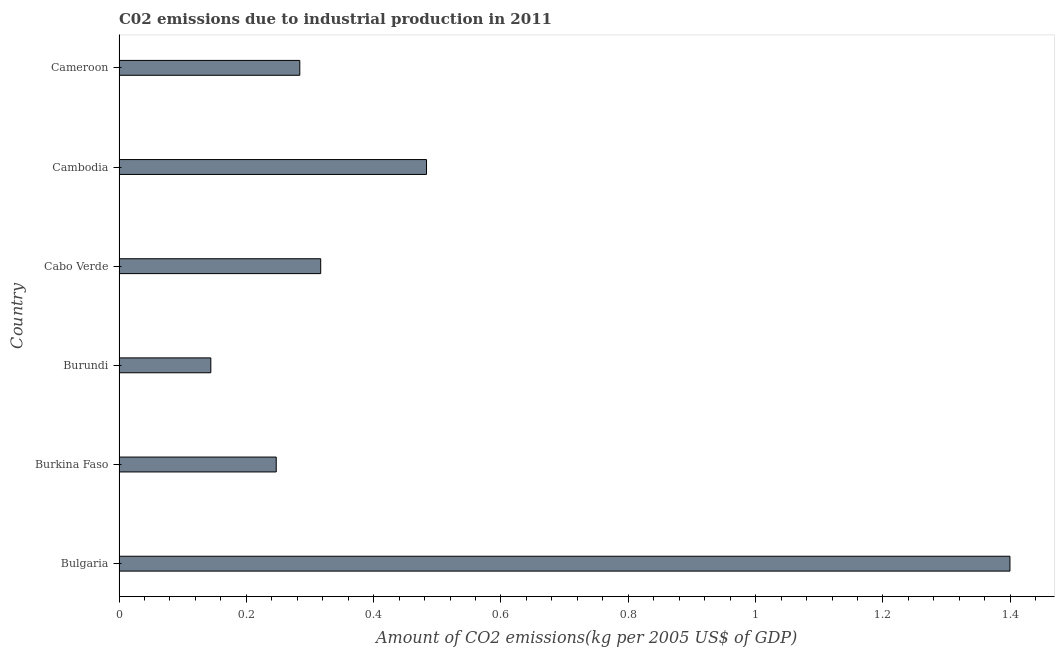Does the graph contain any zero values?
Your answer should be compact. No. What is the title of the graph?
Your answer should be compact. C02 emissions due to industrial production in 2011. What is the label or title of the X-axis?
Make the answer very short. Amount of CO2 emissions(kg per 2005 US$ of GDP). What is the amount of co2 emissions in Cabo Verde?
Your response must be concise. 0.32. Across all countries, what is the maximum amount of co2 emissions?
Provide a succinct answer. 1.4. Across all countries, what is the minimum amount of co2 emissions?
Offer a very short reply. 0.14. In which country was the amount of co2 emissions maximum?
Your answer should be very brief. Bulgaria. In which country was the amount of co2 emissions minimum?
Your response must be concise. Burundi. What is the sum of the amount of co2 emissions?
Your answer should be compact. 2.87. What is the difference between the amount of co2 emissions in Burkina Faso and Cabo Verde?
Offer a terse response. -0.07. What is the average amount of co2 emissions per country?
Offer a very short reply. 0.48. What is the median amount of co2 emissions?
Ensure brevity in your answer.  0.3. What is the ratio of the amount of co2 emissions in Cabo Verde to that in Cambodia?
Keep it short and to the point. 0.66. Is the amount of co2 emissions in Bulgaria less than that in Cameroon?
Give a very brief answer. No. Is the difference between the amount of co2 emissions in Bulgaria and Cabo Verde greater than the difference between any two countries?
Offer a terse response. No. What is the difference between the highest and the second highest amount of co2 emissions?
Make the answer very short. 0.92. What is the difference between the highest and the lowest amount of co2 emissions?
Ensure brevity in your answer.  1.26. Are all the bars in the graph horizontal?
Your answer should be compact. Yes. What is the difference between two consecutive major ticks on the X-axis?
Provide a succinct answer. 0.2. Are the values on the major ticks of X-axis written in scientific E-notation?
Provide a short and direct response. No. What is the Amount of CO2 emissions(kg per 2005 US$ of GDP) of Bulgaria?
Ensure brevity in your answer.  1.4. What is the Amount of CO2 emissions(kg per 2005 US$ of GDP) of Burkina Faso?
Provide a succinct answer. 0.25. What is the Amount of CO2 emissions(kg per 2005 US$ of GDP) of Burundi?
Ensure brevity in your answer.  0.14. What is the Amount of CO2 emissions(kg per 2005 US$ of GDP) in Cabo Verde?
Your answer should be very brief. 0.32. What is the Amount of CO2 emissions(kg per 2005 US$ of GDP) of Cambodia?
Offer a terse response. 0.48. What is the Amount of CO2 emissions(kg per 2005 US$ of GDP) of Cameroon?
Make the answer very short. 0.28. What is the difference between the Amount of CO2 emissions(kg per 2005 US$ of GDP) in Bulgaria and Burkina Faso?
Keep it short and to the point. 1.15. What is the difference between the Amount of CO2 emissions(kg per 2005 US$ of GDP) in Bulgaria and Burundi?
Offer a terse response. 1.26. What is the difference between the Amount of CO2 emissions(kg per 2005 US$ of GDP) in Bulgaria and Cabo Verde?
Provide a short and direct response. 1.08. What is the difference between the Amount of CO2 emissions(kg per 2005 US$ of GDP) in Bulgaria and Cambodia?
Make the answer very short. 0.92. What is the difference between the Amount of CO2 emissions(kg per 2005 US$ of GDP) in Bulgaria and Cameroon?
Give a very brief answer. 1.12. What is the difference between the Amount of CO2 emissions(kg per 2005 US$ of GDP) in Burkina Faso and Burundi?
Offer a terse response. 0.1. What is the difference between the Amount of CO2 emissions(kg per 2005 US$ of GDP) in Burkina Faso and Cabo Verde?
Provide a short and direct response. -0.07. What is the difference between the Amount of CO2 emissions(kg per 2005 US$ of GDP) in Burkina Faso and Cambodia?
Ensure brevity in your answer.  -0.24. What is the difference between the Amount of CO2 emissions(kg per 2005 US$ of GDP) in Burkina Faso and Cameroon?
Ensure brevity in your answer.  -0.04. What is the difference between the Amount of CO2 emissions(kg per 2005 US$ of GDP) in Burundi and Cabo Verde?
Your answer should be compact. -0.17. What is the difference between the Amount of CO2 emissions(kg per 2005 US$ of GDP) in Burundi and Cambodia?
Your answer should be very brief. -0.34. What is the difference between the Amount of CO2 emissions(kg per 2005 US$ of GDP) in Burundi and Cameroon?
Give a very brief answer. -0.14. What is the difference between the Amount of CO2 emissions(kg per 2005 US$ of GDP) in Cabo Verde and Cambodia?
Your answer should be compact. -0.17. What is the difference between the Amount of CO2 emissions(kg per 2005 US$ of GDP) in Cabo Verde and Cameroon?
Ensure brevity in your answer.  0.03. What is the difference between the Amount of CO2 emissions(kg per 2005 US$ of GDP) in Cambodia and Cameroon?
Keep it short and to the point. 0.2. What is the ratio of the Amount of CO2 emissions(kg per 2005 US$ of GDP) in Bulgaria to that in Burkina Faso?
Provide a succinct answer. 5.67. What is the ratio of the Amount of CO2 emissions(kg per 2005 US$ of GDP) in Bulgaria to that in Burundi?
Make the answer very short. 9.71. What is the ratio of the Amount of CO2 emissions(kg per 2005 US$ of GDP) in Bulgaria to that in Cabo Verde?
Make the answer very short. 4.42. What is the ratio of the Amount of CO2 emissions(kg per 2005 US$ of GDP) in Bulgaria to that in Cambodia?
Offer a very short reply. 2.9. What is the ratio of the Amount of CO2 emissions(kg per 2005 US$ of GDP) in Bulgaria to that in Cameroon?
Your response must be concise. 4.93. What is the ratio of the Amount of CO2 emissions(kg per 2005 US$ of GDP) in Burkina Faso to that in Burundi?
Provide a succinct answer. 1.71. What is the ratio of the Amount of CO2 emissions(kg per 2005 US$ of GDP) in Burkina Faso to that in Cabo Verde?
Ensure brevity in your answer.  0.78. What is the ratio of the Amount of CO2 emissions(kg per 2005 US$ of GDP) in Burkina Faso to that in Cambodia?
Your answer should be very brief. 0.51. What is the ratio of the Amount of CO2 emissions(kg per 2005 US$ of GDP) in Burkina Faso to that in Cameroon?
Give a very brief answer. 0.87. What is the ratio of the Amount of CO2 emissions(kg per 2005 US$ of GDP) in Burundi to that in Cabo Verde?
Ensure brevity in your answer.  0.46. What is the ratio of the Amount of CO2 emissions(kg per 2005 US$ of GDP) in Burundi to that in Cambodia?
Offer a very short reply. 0.3. What is the ratio of the Amount of CO2 emissions(kg per 2005 US$ of GDP) in Burundi to that in Cameroon?
Your response must be concise. 0.51. What is the ratio of the Amount of CO2 emissions(kg per 2005 US$ of GDP) in Cabo Verde to that in Cambodia?
Ensure brevity in your answer.  0.66. What is the ratio of the Amount of CO2 emissions(kg per 2005 US$ of GDP) in Cabo Verde to that in Cameroon?
Your response must be concise. 1.12. What is the ratio of the Amount of CO2 emissions(kg per 2005 US$ of GDP) in Cambodia to that in Cameroon?
Offer a terse response. 1.7. 